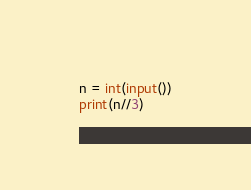<code> <loc_0><loc_0><loc_500><loc_500><_Python_>n = int(input())
print(n//3)
</code> 